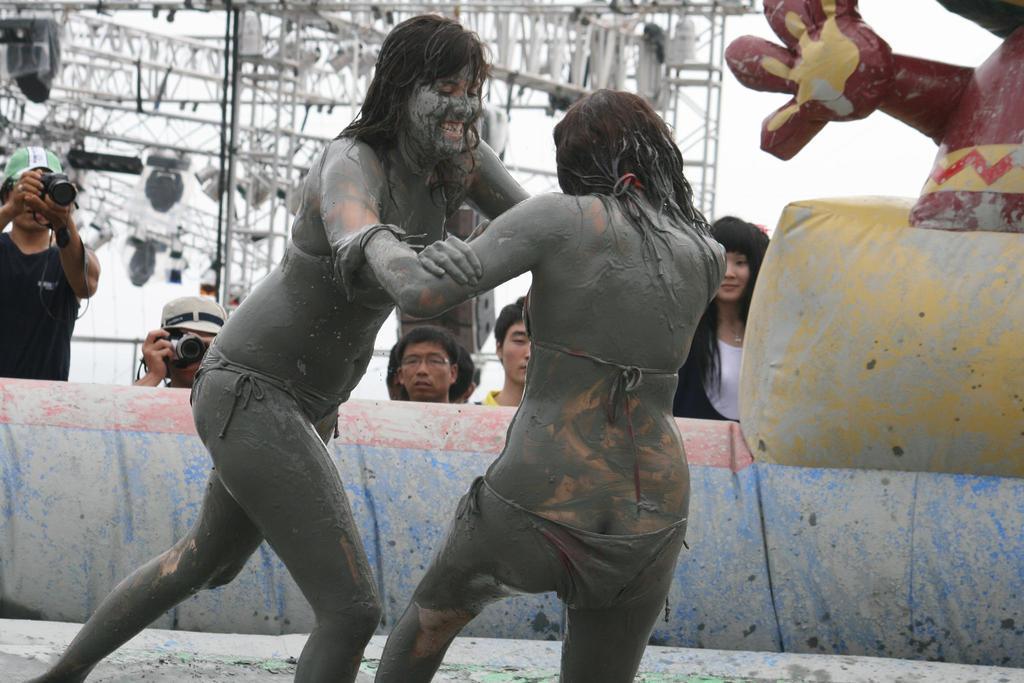In one or two sentences, can you explain what this image depicts? In this image we can see there are two people fighting. And there is a doll shape balloon. At the back there are a few people standing and few people holding a camera. And there is a crane with lights and the sky. 